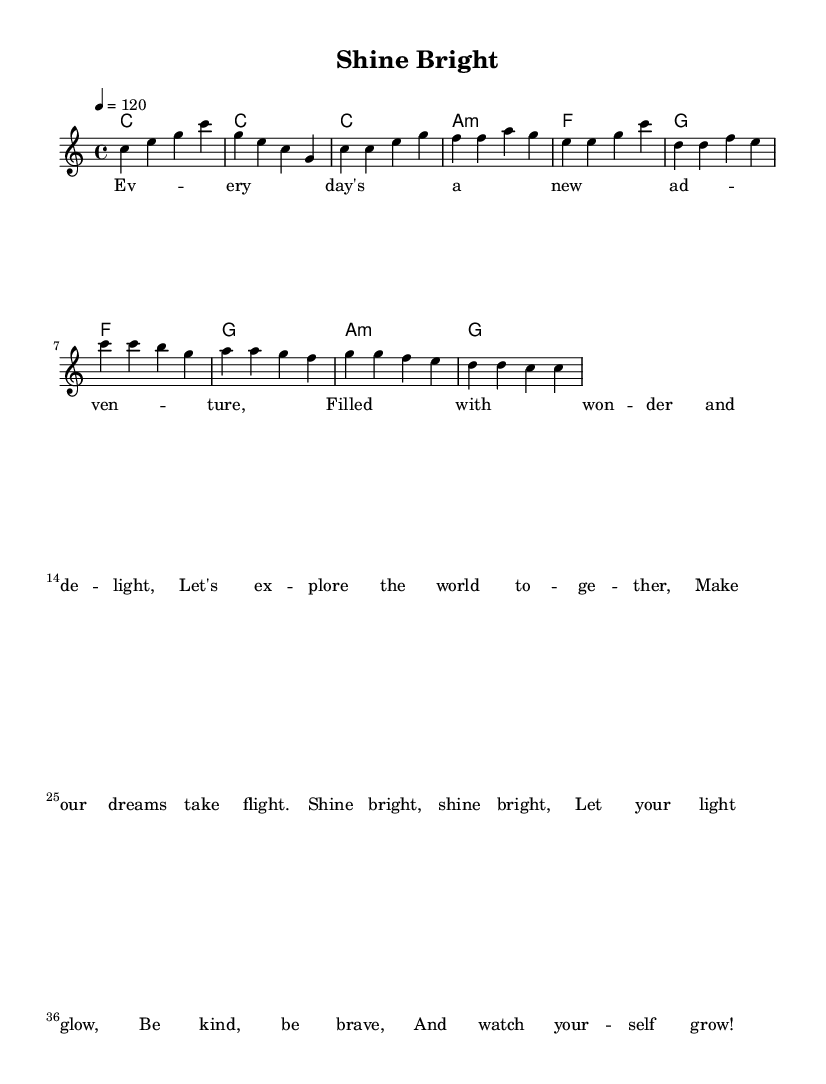What is the key signature of this music? The key signature is indicated at the beginning of the staff. In this case, it shows no sharps or flats, which signifies C major.
Answer: C major What is the time signature of the piece? The time signature is also located at the beginning of the score, showing a "4/4" which means there are four beats in each measure and the quarter note gets one beat.
Answer: 4/4 What is the tempo marking of the piece? The tempo marking is shown in beats per minute, indicated by "4 = 120". It means there are 120 beats in one minute in a quarter note tempo.
Answer: 120 How many measures are in the verse section? The verse section is defined by the melody, and by counting the measures in the verse part, we can see there are four measures total. Each line of the melody typically corresponds to one measure.
Answer: 4 What type of chords are used in the harmony section? The chord mode indicates the harmonic structure used. It employs major and minor chords: C major, A minor, and F major are evident from the symbols present in the harmony section.
Answer: Major and minor chords What is the primary message of the lyrics? Analyzing the lyrics reveals themes of positivity, exploration, and personal growth, encapsulated in phrases such as "shine bright" and "be kind, be brave". These evoke uplifting and encouraging sentiments suitable for children.
Answer: Positivity 